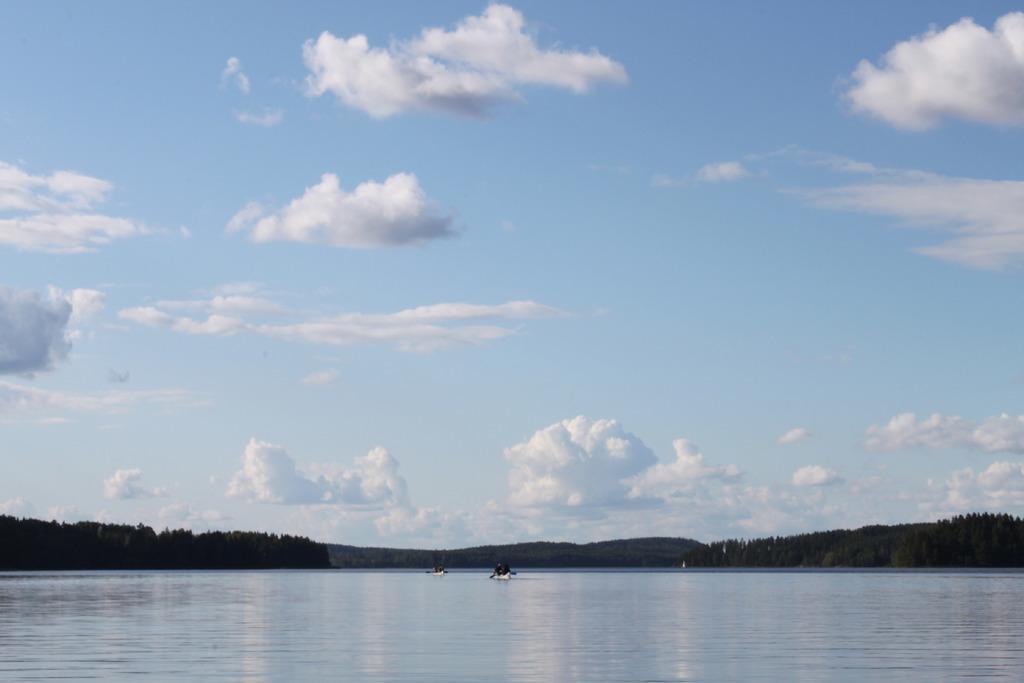Describe this image in one or two sentences. At the bottom of the image, we can see few people are sailing boats on the water. Here we can see trees and hills. Background there is a cloudy sky. 